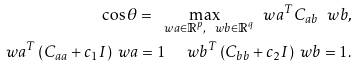<formula> <loc_0><loc_0><loc_500><loc_500>\cos \theta = \max _ { \ w a \in \mathbb { R } ^ { p } , \ w b \in \mathbb { R } ^ { q } } \ w a ^ { T } C _ { a b } \ w b , \\ \ w a ^ { T } \left ( C _ { a a } + c _ { 1 } I \right ) \ w a = 1 \quad \ w b ^ { T } \left ( C _ { b b } + c _ { 2 } I \right ) \ w b = 1 .</formula> 